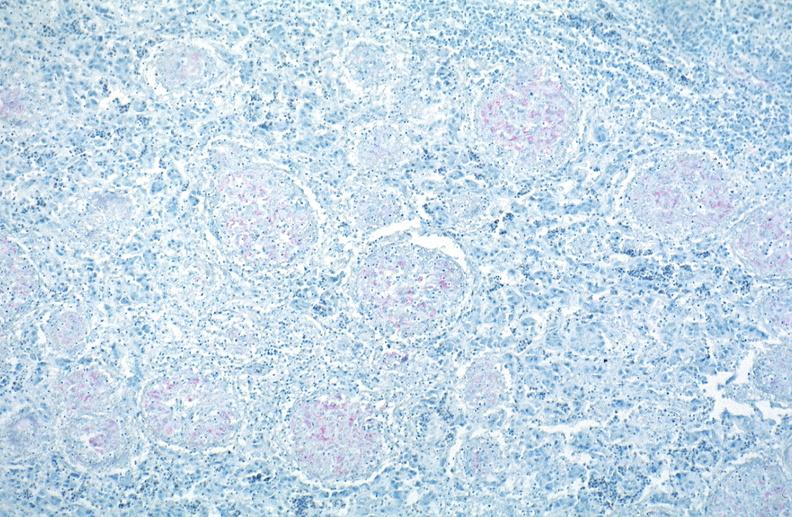what is present?
Answer the question using a single word or phrase. Respiratory 